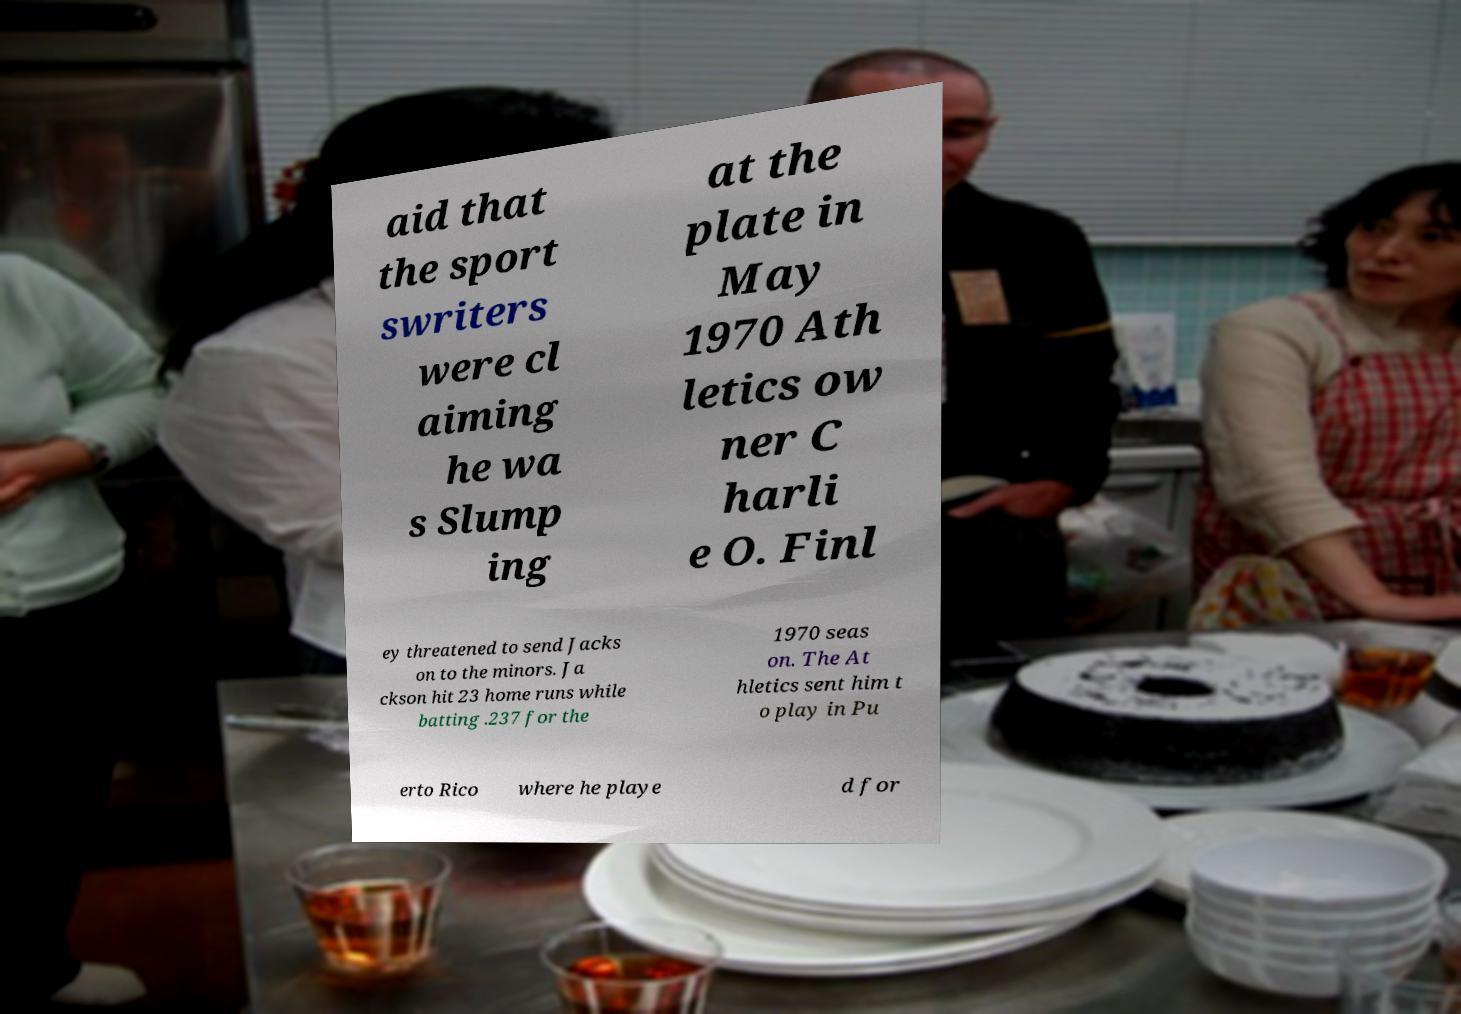Could you assist in decoding the text presented in this image and type it out clearly? aid that the sport swriters were cl aiming he wa s Slump ing at the plate in May 1970 Ath letics ow ner C harli e O. Finl ey threatened to send Jacks on to the minors. Ja ckson hit 23 home runs while batting .237 for the 1970 seas on. The At hletics sent him t o play in Pu erto Rico where he playe d for 